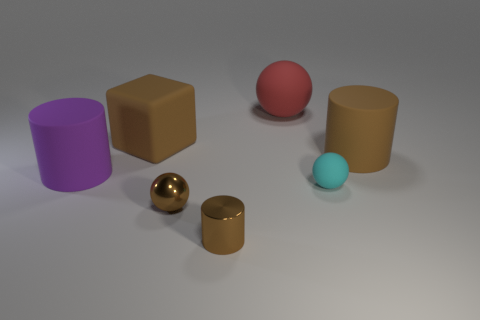Add 3 brown shiny cylinders. How many objects exist? 10 Subtract all blocks. How many objects are left? 6 Add 7 tiny cylinders. How many tiny cylinders exist? 8 Subtract 0 gray cylinders. How many objects are left? 7 Subtract all tiny cyan rubber spheres. Subtract all small red cubes. How many objects are left? 6 Add 1 tiny cyan balls. How many tiny cyan balls are left? 2 